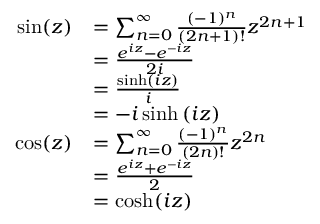Convert formula to latex. <formula><loc_0><loc_0><loc_500><loc_500>{ \begin{array} { r l } { \sin ( z ) } & { = \sum _ { n = 0 } ^ { \infty } { \frac { ( - 1 ) ^ { n } } { ( 2 n + 1 ) ! } } z ^ { 2 n + 1 } } \\ & { = { \frac { e ^ { i z } - e ^ { - i z } } { 2 i } } } \\ & { = { \frac { \sinh \left ( i z \right ) } { i } } } \\ & { = - i \sinh \left ( i z \right ) } \\ { \cos ( z ) } & { = \sum _ { n = 0 } ^ { \infty } { \frac { ( - 1 ) ^ { n } } { ( 2 n ) ! } } z ^ { 2 n } } \\ & { = { \frac { e ^ { i z } + e ^ { - i z } } { 2 } } } \\ & { = \cosh ( i z ) } \end{array} }</formula> 